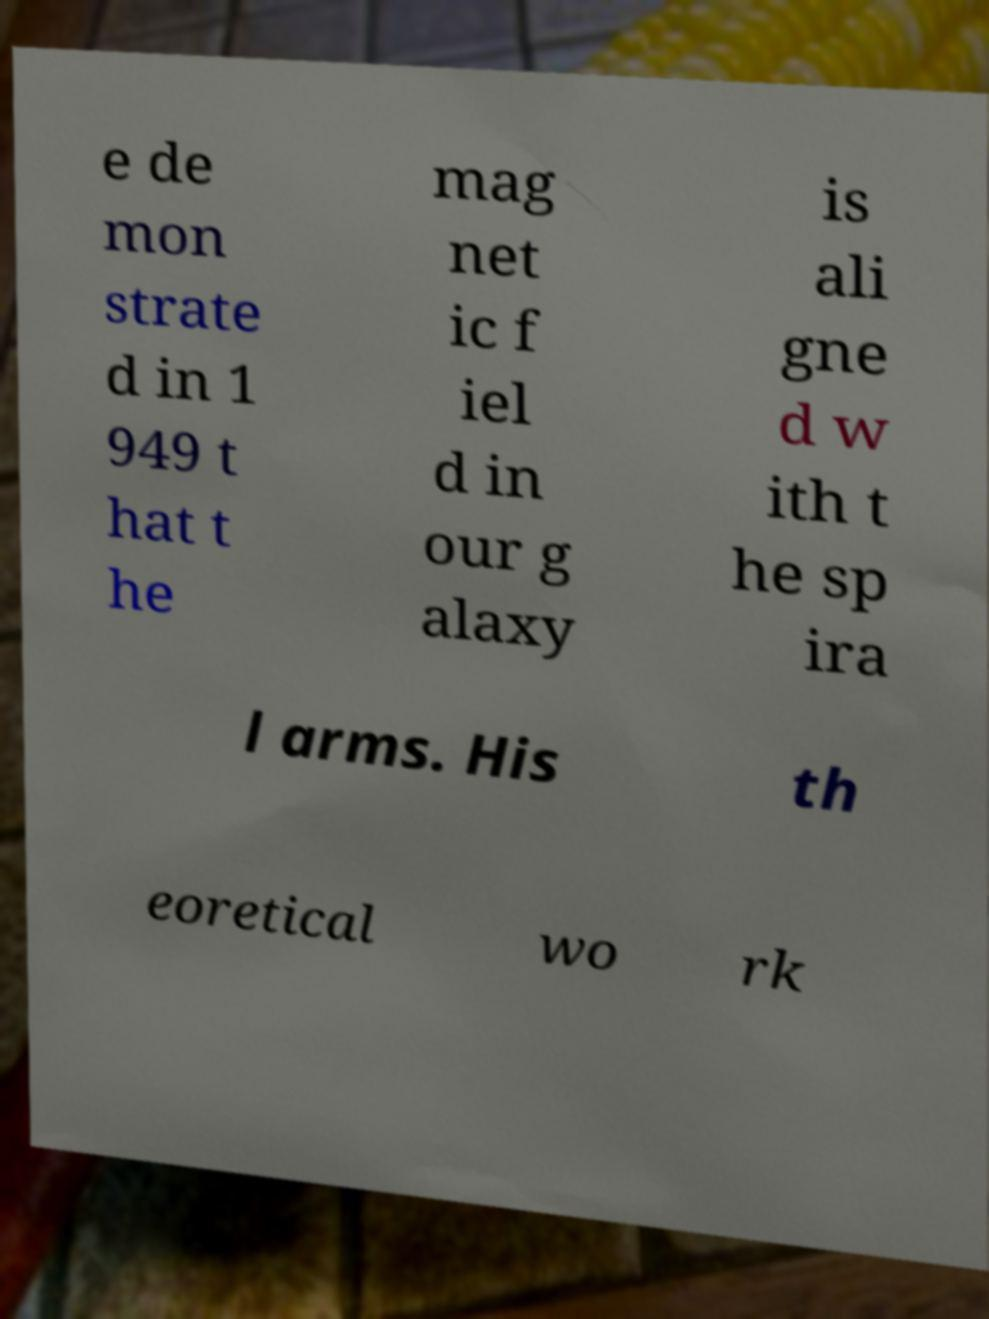Please identify and transcribe the text found in this image. e de mon strate d in 1 949 t hat t he mag net ic f iel d in our g alaxy is ali gne d w ith t he sp ira l arms. His th eoretical wo rk 